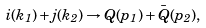Convert formula to latex. <formula><loc_0><loc_0><loc_500><loc_500>i ( k _ { 1 } ) + j ( k _ { 2 } ) \rightarrow Q ( p _ { 1 } ) + \bar { Q } ( p _ { 2 } ) ,</formula> 